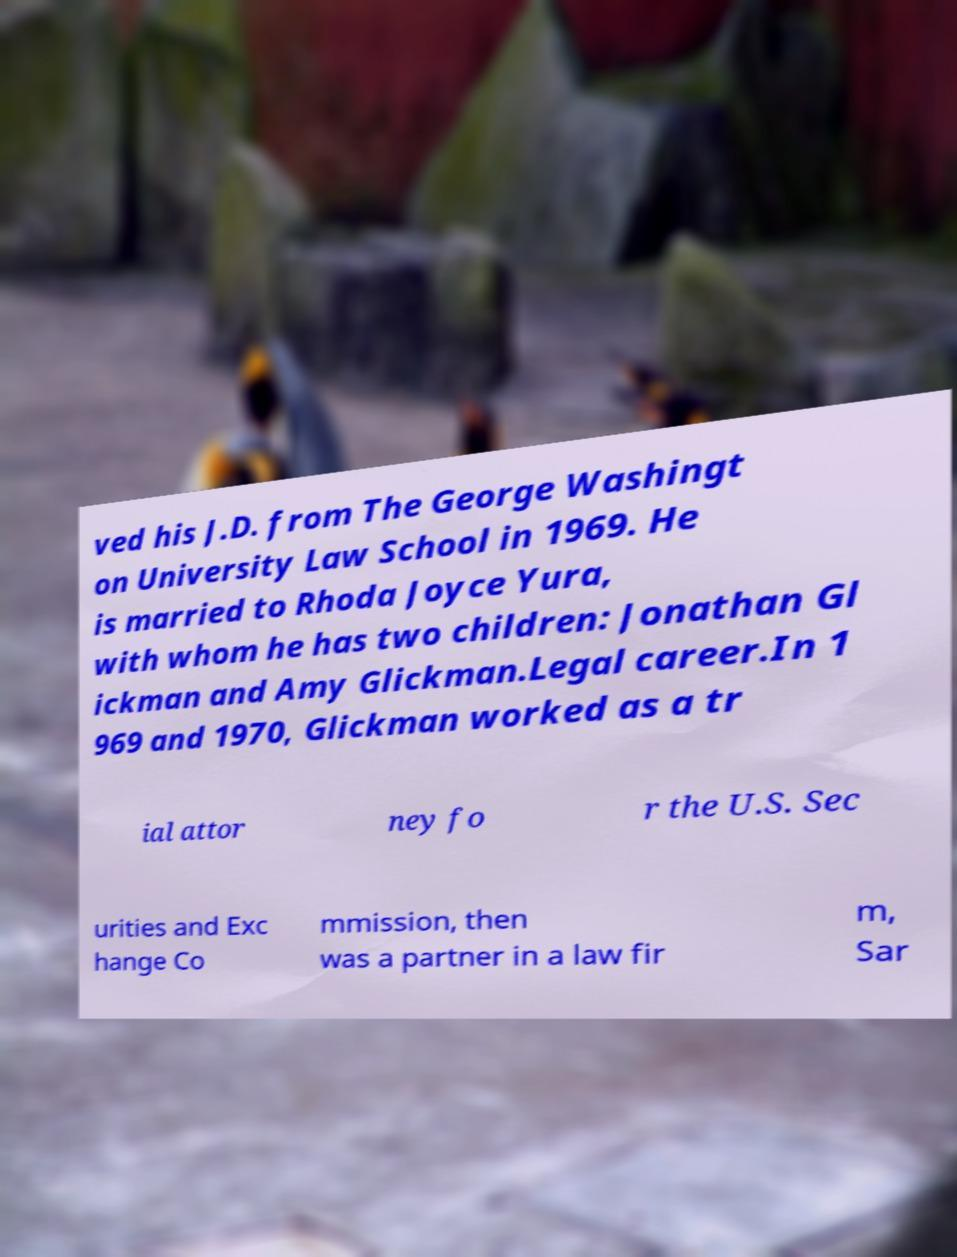What messages or text are displayed in this image? I need them in a readable, typed format. ved his J.D. from The George Washingt on University Law School in 1969. He is married to Rhoda Joyce Yura, with whom he has two children: Jonathan Gl ickman and Amy Glickman.Legal career.In 1 969 and 1970, Glickman worked as a tr ial attor ney fo r the U.S. Sec urities and Exc hange Co mmission, then was a partner in a law fir m, Sar 